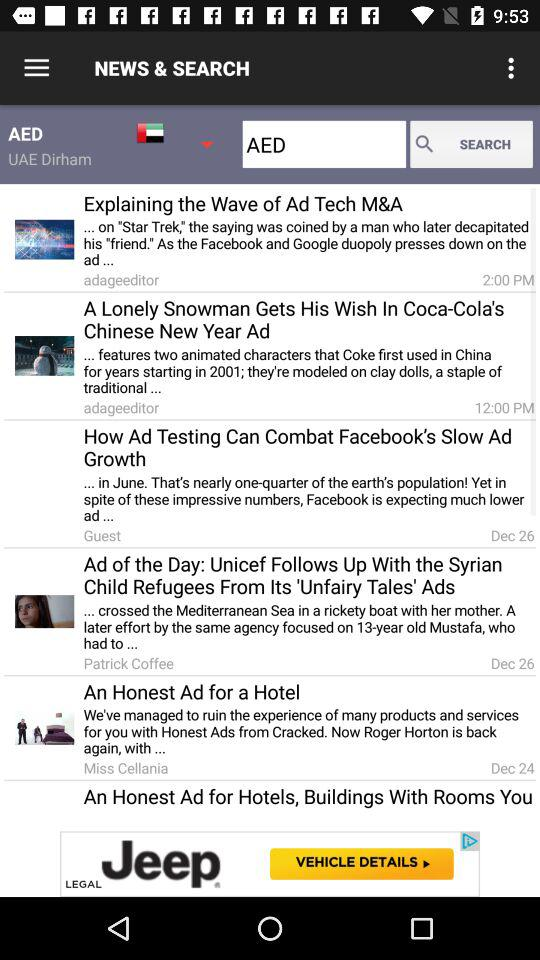At what time was the "Explaining the Wave of Ad Tech M&A" article published? It was published at 2:00 PM. 